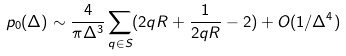Convert formula to latex. <formula><loc_0><loc_0><loc_500><loc_500>p _ { 0 } ( \Delta ) \sim \frac { 4 } { \pi \Delta ^ { 3 } } \sum _ { { q } \in S } ( 2 q R + \frac { 1 } { 2 q R } - 2 ) + O ( 1 / \Delta ^ { 4 } )</formula> 